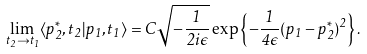Convert formula to latex. <formula><loc_0><loc_0><loc_500><loc_500>\lim _ { t _ { 2 } \rightarrow t _ { 1 } } \langle p _ { 2 } ^ { \ast } , t _ { 2 } | p _ { 1 } , t _ { 1 } \rangle = C \sqrt { - \frac { 1 } { 2 i \epsilon } } \exp \left \{ - \frac { 1 } { 4 \epsilon } ( p _ { 1 } - p _ { 2 } ^ { \ast } ) ^ { 2 } \right \} .</formula> 